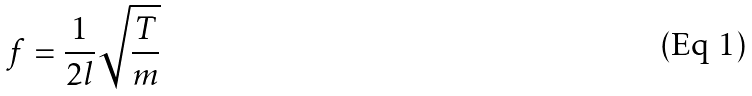<formula> <loc_0><loc_0><loc_500><loc_500>f = \frac { 1 } { 2 l } \sqrt { \frac { T } { m } }</formula> 